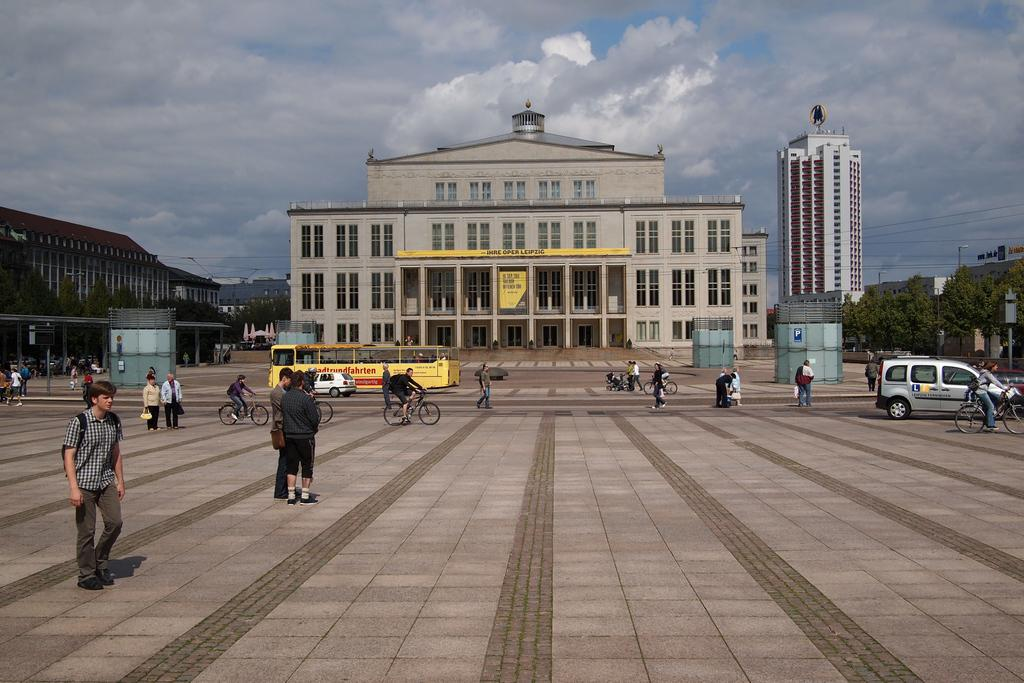What can be seen in the background of the image? In the background of the image, there is a sky with clouds, buildings, and trees. What mode of transportation is present in the image? There is a bus and cars in the image. What are the people in the image doing? There are people standing, walking, and riding bicycles in the image. What type of stamp can be seen on the bedroom wall in the image? There is no bedroom or stamp present in the image. How does the attention of the people in the image change throughout the day? The image does not provide information about the attention of the people or how it changes throughout the day. 